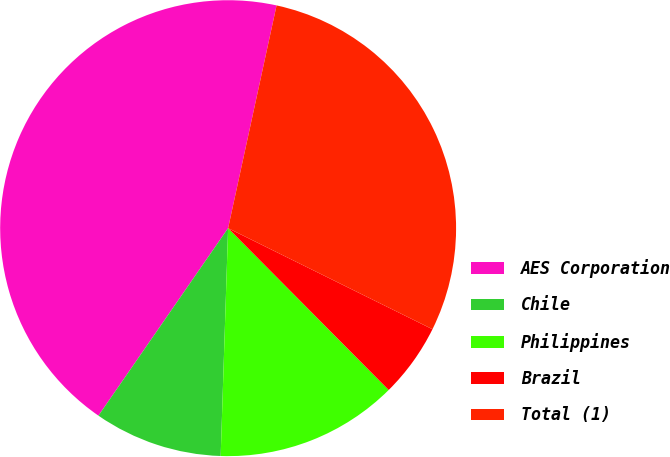Convert chart to OTSL. <chart><loc_0><loc_0><loc_500><loc_500><pie_chart><fcel>AES Corporation<fcel>Chile<fcel>Philippines<fcel>Brazil<fcel>Total (1)<nl><fcel>43.78%<fcel>9.11%<fcel>12.96%<fcel>5.25%<fcel>28.9%<nl></chart> 